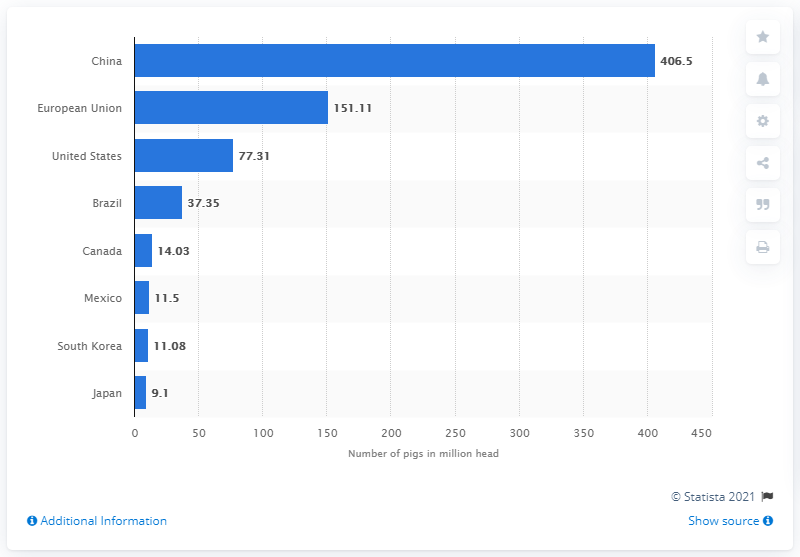Give some essential details in this illustration. As of April 2021, it is estimated that China had 406.5 million pigs. In April of 2021, there were 77,310 pigs in the United States. 